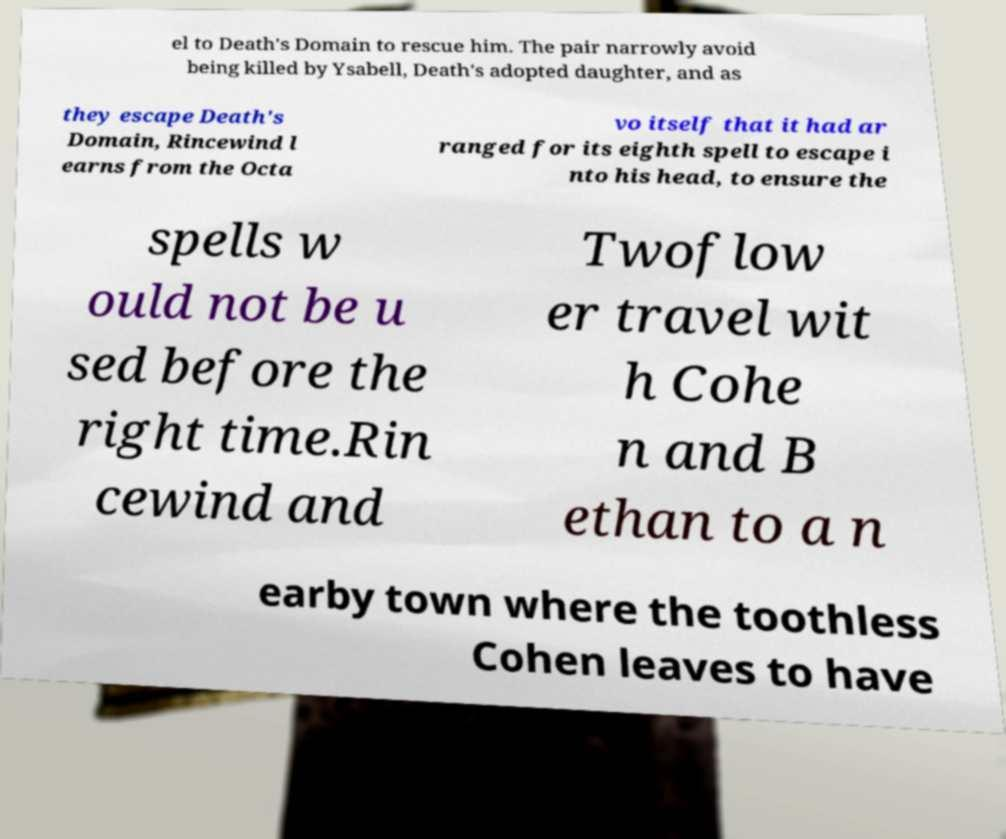Can you accurately transcribe the text from the provided image for me? el to Death's Domain to rescue him. The pair narrowly avoid being killed by Ysabell, Death's adopted daughter, and as they escape Death's Domain, Rincewind l earns from the Octa vo itself that it had ar ranged for its eighth spell to escape i nto his head, to ensure the spells w ould not be u sed before the right time.Rin cewind and Twoflow er travel wit h Cohe n and B ethan to a n earby town where the toothless Cohen leaves to have 